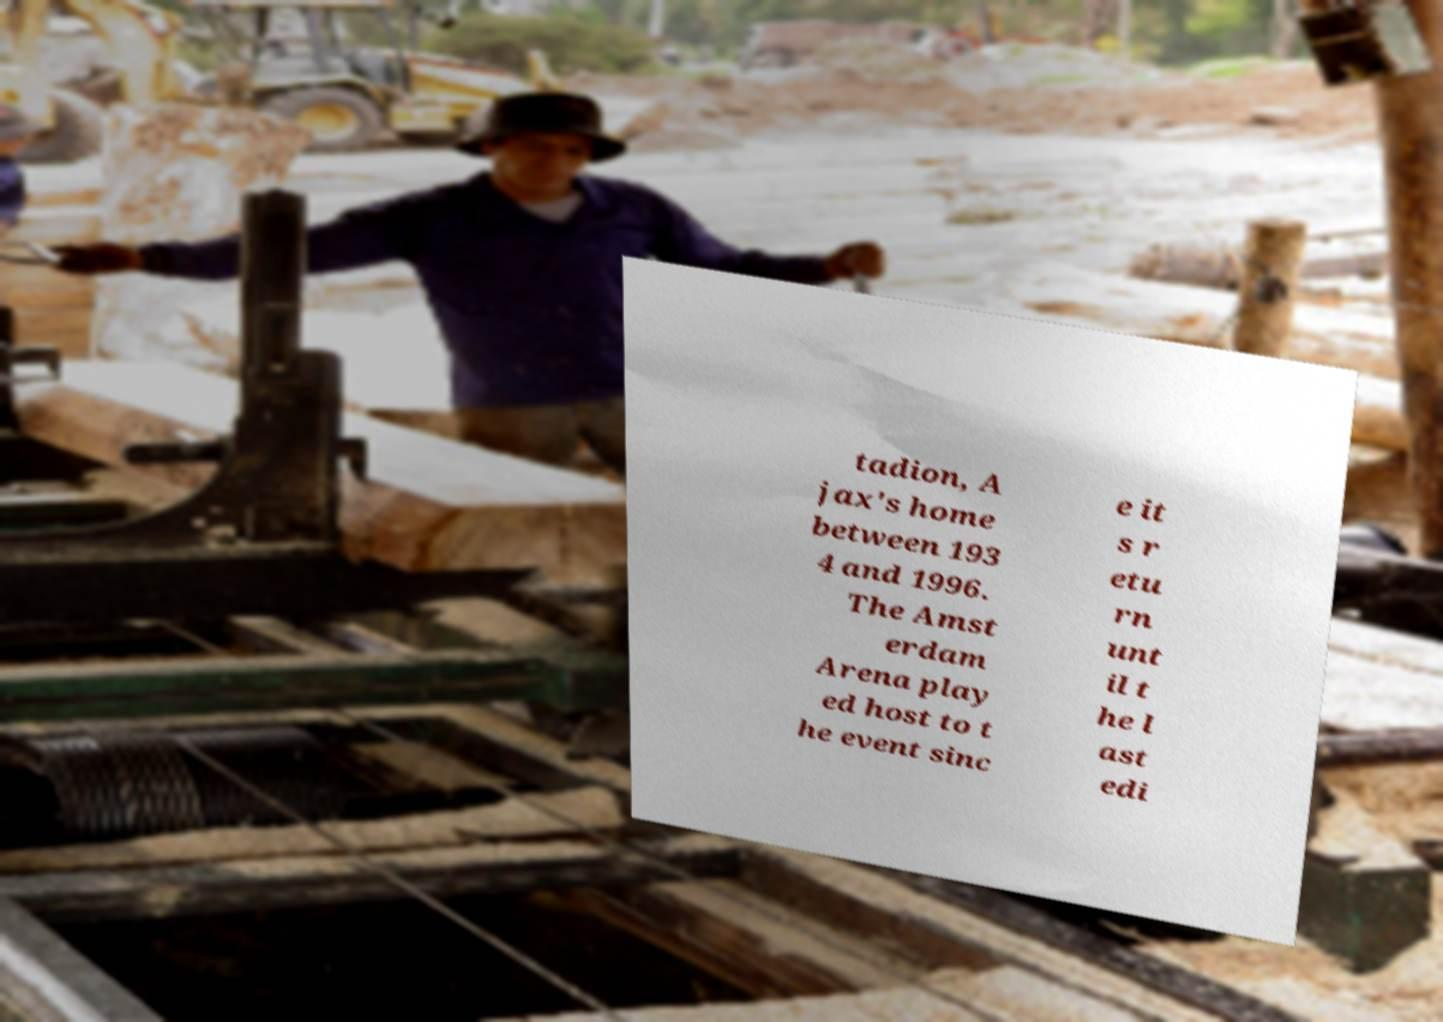I need the written content from this picture converted into text. Can you do that? tadion, A jax's home between 193 4 and 1996. The Amst erdam Arena play ed host to t he event sinc e it s r etu rn unt il t he l ast edi 